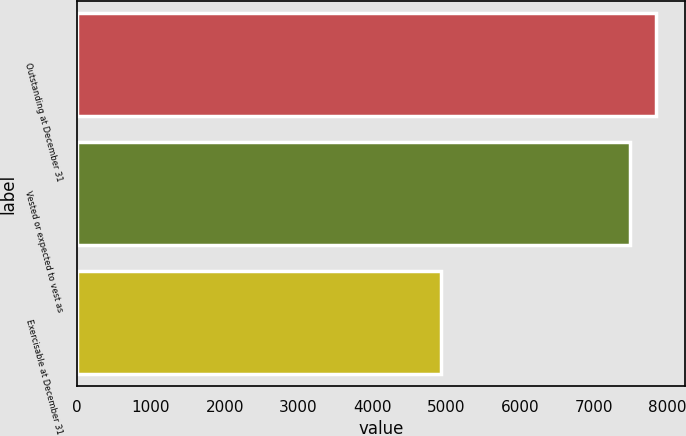Convert chart to OTSL. <chart><loc_0><loc_0><loc_500><loc_500><bar_chart><fcel>Outstanding at December 31<fcel>Vested or expected to vest as<fcel>Exercisable at December 31<nl><fcel>7846<fcel>7485<fcel>4927<nl></chart> 